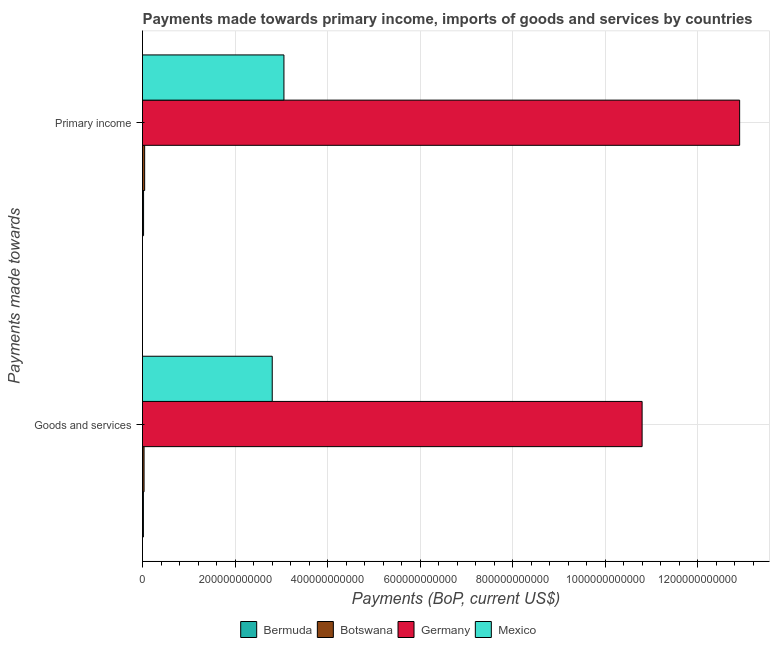How many different coloured bars are there?
Ensure brevity in your answer.  4. Are the number of bars per tick equal to the number of legend labels?
Your response must be concise. Yes. Are the number of bars on each tick of the Y-axis equal?
Provide a short and direct response. Yes. How many bars are there on the 2nd tick from the bottom?
Offer a terse response. 4. What is the label of the 2nd group of bars from the top?
Keep it short and to the point. Goods and services. What is the payments made towards goods and services in Botswana?
Provide a succinct answer. 3.35e+09. Across all countries, what is the maximum payments made towards primary income?
Your response must be concise. 1.29e+12. Across all countries, what is the minimum payments made towards primary income?
Offer a very short reply. 2.28e+09. In which country was the payments made towards primary income maximum?
Provide a succinct answer. Germany. In which country was the payments made towards goods and services minimum?
Your answer should be very brief. Bermuda. What is the total payments made towards primary income in the graph?
Your response must be concise. 1.60e+12. What is the difference between the payments made towards goods and services in Bermuda and that in Germany?
Provide a short and direct response. -1.08e+12. What is the difference between the payments made towards goods and services in Germany and the payments made towards primary income in Mexico?
Your response must be concise. 7.74e+11. What is the average payments made towards primary income per country?
Provide a succinct answer. 4.01e+11. What is the difference between the payments made towards primary income and payments made towards goods and services in Bermuda?
Offer a very short reply. 3.23e+08. What is the ratio of the payments made towards primary income in Botswana to that in Germany?
Make the answer very short. 0. What does the 1st bar from the top in Primary income represents?
Offer a terse response. Mexico. What does the 1st bar from the bottom in Goods and services represents?
Your response must be concise. Bermuda. How many bars are there?
Provide a succinct answer. 8. Are all the bars in the graph horizontal?
Provide a succinct answer. Yes. How many countries are there in the graph?
Offer a very short reply. 4. What is the difference between two consecutive major ticks on the X-axis?
Give a very brief answer. 2.00e+11. Are the values on the major ticks of X-axis written in scientific E-notation?
Your answer should be very brief. No. Does the graph contain any zero values?
Keep it short and to the point. No. Does the graph contain grids?
Give a very brief answer. Yes. Where does the legend appear in the graph?
Your response must be concise. Bottom center. How many legend labels are there?
Provide a succinct answer. 4. How are the legend labels stacked?
Give a very brief answer. Horizontal. What is the title of the graph?
Your response must be concise. Payments made towards primary income, imports of goods and services by countries. What is the label or title of the X-axis?
Keep it short and to the point. Payments (BoP, current US$). What is the label or title of the Y-axis?
Offer a terse response. Payments made towards. What is the Payments (BoP, current US$) in Bermuda in Goods and services?
Your answer should be compact. 1.96e+09. What is the Payments (BoP, current US$) of Botswana in Goods and services?
Keep it short and to the point. 3.35e+09. What is the Payments (BoP, current US$) in Germany in Goods and services?
Offer a terse response. 1.08e+12. What is the Payments (BoP, current US$) of Mexico in Goods and services?
Make the answer very short. 2.80e+11. What is the Payments (BoP, current US$) in Bermuda in Primary income?
Your answer should be compact. 2.28e+09. What is the Payments (BoP, current US$) in Botswana in Primary income?
Your answer should be compact. 4.65e+09. What is the Payments (BoP, current US$) of Germany in Primary income?
Your answer should be compact. 1.29e+12. What is the Payments (BoP, current US$) of Mexico in Primary income?
Your response must be concise. 3.06e+11. Across all Payments made towards, what is the maximum Payments (BoP, current US$) in Bermuda?
Offer a very short reply. 2.28e+09. Across all Payments made towards, what is the maximum Payments (BoP, current US$) in Botswana?
Give a very brief answer. 4.65e+09. Across all Payments made towards, what is the maximum Payments (BoP, current US$) of Germany?
Give a very brief answer. 1.29e+12. Across all Payments made towards, what is the maximum Payments (BoP, current US$) of Mexico?
Make the answer very short. 3.06e+11. Across all Payments made towards, what is the minimum Payments (BoP, current US$) of Bermuda?
Keep it short and to the point. 1.96e+09. Across all Payments made towards, what is the minimum Payments (BoP, current US$) in Botswana?
Offer a terse response. 3.35e+09. Across all Payments made towards, what is the minimum Payments (BoP, current US$) of Germany?
Offer a very short reply. 1.08e+12. Across all Payments made towards, what is the minimum Payments (BoP, current US$) in Mexico?
Your answer should be very brief. 2.80e+11. What is the total Payments (BoP, current US$) of Bermuda in the graph?
Make the answer very short. 4.24e+09. What is the total Payments (BoP, current US$) of Botswana in the graph?
Provide a short and direct response. 8.01e+09. What is the total Payments (BoP, current US$) in Germany in the graph?
Provide a short and direct response. 2.37e+12. What is the total Payments (BoP, current US$) in Mexico in the graph?
Ensure brevity in your answer.  5.86e+11. What is the difference between the Payments (BoP, current US$) of Bermuda in Goods and services and that in Primary income?
Your answer should be compact. -3.23e+08. What is the difference between the Payments (BoP, current US$) of Botswana in Goods and services and that in Primary income?
Make the answer very short. -1.30e+09. What is the difference between the Payments (BoP, current US$) in Germany in Goods and services and that in Primary income?
Your answer should be very brief. -2.11e+11. What is the difference between the Payments (BoP, current US$) in Mexico in Goods and services and that in Primary income?
Your answer should be compact. -2.53e+1. What is the difference between the Payments (BoP, current US$) in Bermuda in Goods and services and the Payments (BoP, current US$) in Botswana in Primary income?
Provide a succinct answer. -2.70e+09. What is the difference between the Payments (BoP, current US$) of Bermuda in Goods and services and the Payments (BoP, current US$) of Germany in Primary income?
Make the answer very short. -1.29e+12. What is the difference between the Payments (BoP, current US$) of Bermuda in Goods and services and the Payments (BoP, current US$) of Mexico in Primary income?
Provide a short and direct response. -3.04e+11. What is the difference between the Payments (BoP, current US$) of Botswana in Goods and services and the Payments (BoP, current US$) of Germany in Primary income?
Offer a very short reply. -1.29e+12. What is the difference between the Payments (BoP, current US$) in Botswana in Goods and services and the Payments (BoP, current US$) in Mexico in Primary income?
Ensure brevity in your answer.  -3.02e+11. What is the difference between the Payments (BoP, current US$) in Germany in Goods and services and the Payments (BoP, current US$) in Mexico in Primary income?
Your response must be concise. 7.74e+11. What is the average Payments (BoP, current US$) in Bermuda per Payments made towards?
Give a very brief answer. 2.12e+09. What is the average Payments (BoP, current US$) in Botswana per Payments made towards?
Provide a succinct answer. 4.00e+09. What is the average Payments (BoP, current US$) of Germany per Payments made towards?
Your answer should be compact. 1.18e+12. What is the average Payments (BoP, current US$) of Mexico per Payments made towards?
Offer a terse response. 2.93e+11. What is the difference between the Payments (BoP, current US$) of Bermuda and Payments (BoP, current US$) of Botswana in Goods and services?
Make the answer very short. -1.40e+09. What is the difference between the Payments (BoP, current US$) in Bermuda and Payments (BoP, current US$) in Germany in Goods and services?
Provide a short and direct response. -1.08e+12. What is the difference between the Payments (BoP, current US$) of Bermuda and Payments (BoP, current US$) of Mexico in Goods and services?
Keep it short and to the point. -2.78e+11. What is the difference between the Payments (BoP, current US$) in Botswana and Payments (BoP, current US$) in Germany in Goods and services?
Ensure brevity in your answer.  -1.08e+12. What is the difference between the Payments (BoP, current US$) of Botswana and Payments (BoP, current US$) of Mexico in Goods and services?
Offer a terse response. -2.77e+11. What is the difference between the Payments (BoP, current US$) in Germany and Payments (BoP, current US$) in Mexico in Goods and services?
Offer a very short reply. 7.99e+11. What is the difference between the Payments (BoP, current US$) in Bermuda and Payments (BoP, current US$) in Botswana in Primary income?
Make the answer very short. -2.37e+09. What is the difference between the Payments (BoP, current US$) in Bermuda and Payments (BoP, current US$) in Germany in Primary income?
Give a very brief answer. -1.29e+12. What is the difference between the Payments (BoP, current US$) of Bermuda and Payments (BoP, current US$) of Mexico in Primary income?
Provide a succinct answer. -3.03e+11. What is the difference between the Payments (BoP, current US$) in Botswana and Payments (BoP, current US$) in Germany in Primary income?
Provide a short and direct response. -1.29e+12. What is the difference between the Payments (BoP, current US$) of Botswana and Payments (BoP, current US$) of Mexico in Primary income?
Offer a terse response. -3.01e+11. What is the difference between the Payments (BoP, current US$) of Germany and Payments (BoP, current US$) of Mexico in Primary income?
Offer a terse response. 9.85e+11. What is the ratio of the Payments (BoP, current US$) of Bermuda in Goods and services to that in Primary income?
Your answer should be very brief. 0.86. What is the ratio of the Payments (BoP, current US$) in Botswana in Goods and services to that in Primary income?
Your response must be concise. 0.72. What is the ratio of the Payments (BoP, current US$) in Germany in Goods and services to that in Primary income?
Offer a terse response. 0.84. What is the ratio of the Payments (BoP, current US$) in Mexico in Goods and services to that in Primary income?
Offer a terse response. 0.92. What is the difference between the highest and the second highest Payments (BoP, current US$) in Bermuda?
Make the answer very short. 3.23e+08. What is the difference between the highest and the second highest Payments (BoP, current US$) in Botswana?
Give a very brief answer. 1.30e+09. What is the difference between the highest and the second highest Payments (BoP, current US$) of Germany?
Your answer should be very brief. 2.11e+11. What is the difference between the highest and the second highest Payments (BoP, current US$) of Mexico?
Make the answer very short. 2.53e+1. What is the difference between the highest and the lowest Payments (BoP, current US$) in Bermuda?
Provide a short and direct response. 3.23e+08. What is the difference between the highest and the lowest Payments (BoP, current US$) in Botswana?
Make the answer very short. 1.30e+09. What is the difference between the highest and the lowest Payments (BoP, current US$) of Germany?
Make the answer very short. 2.11e+11. What is the difference between the highest and the lowest Payments (BoP, current US$) of Mexico?
Keep it short and to the point. 2.53e+1. 